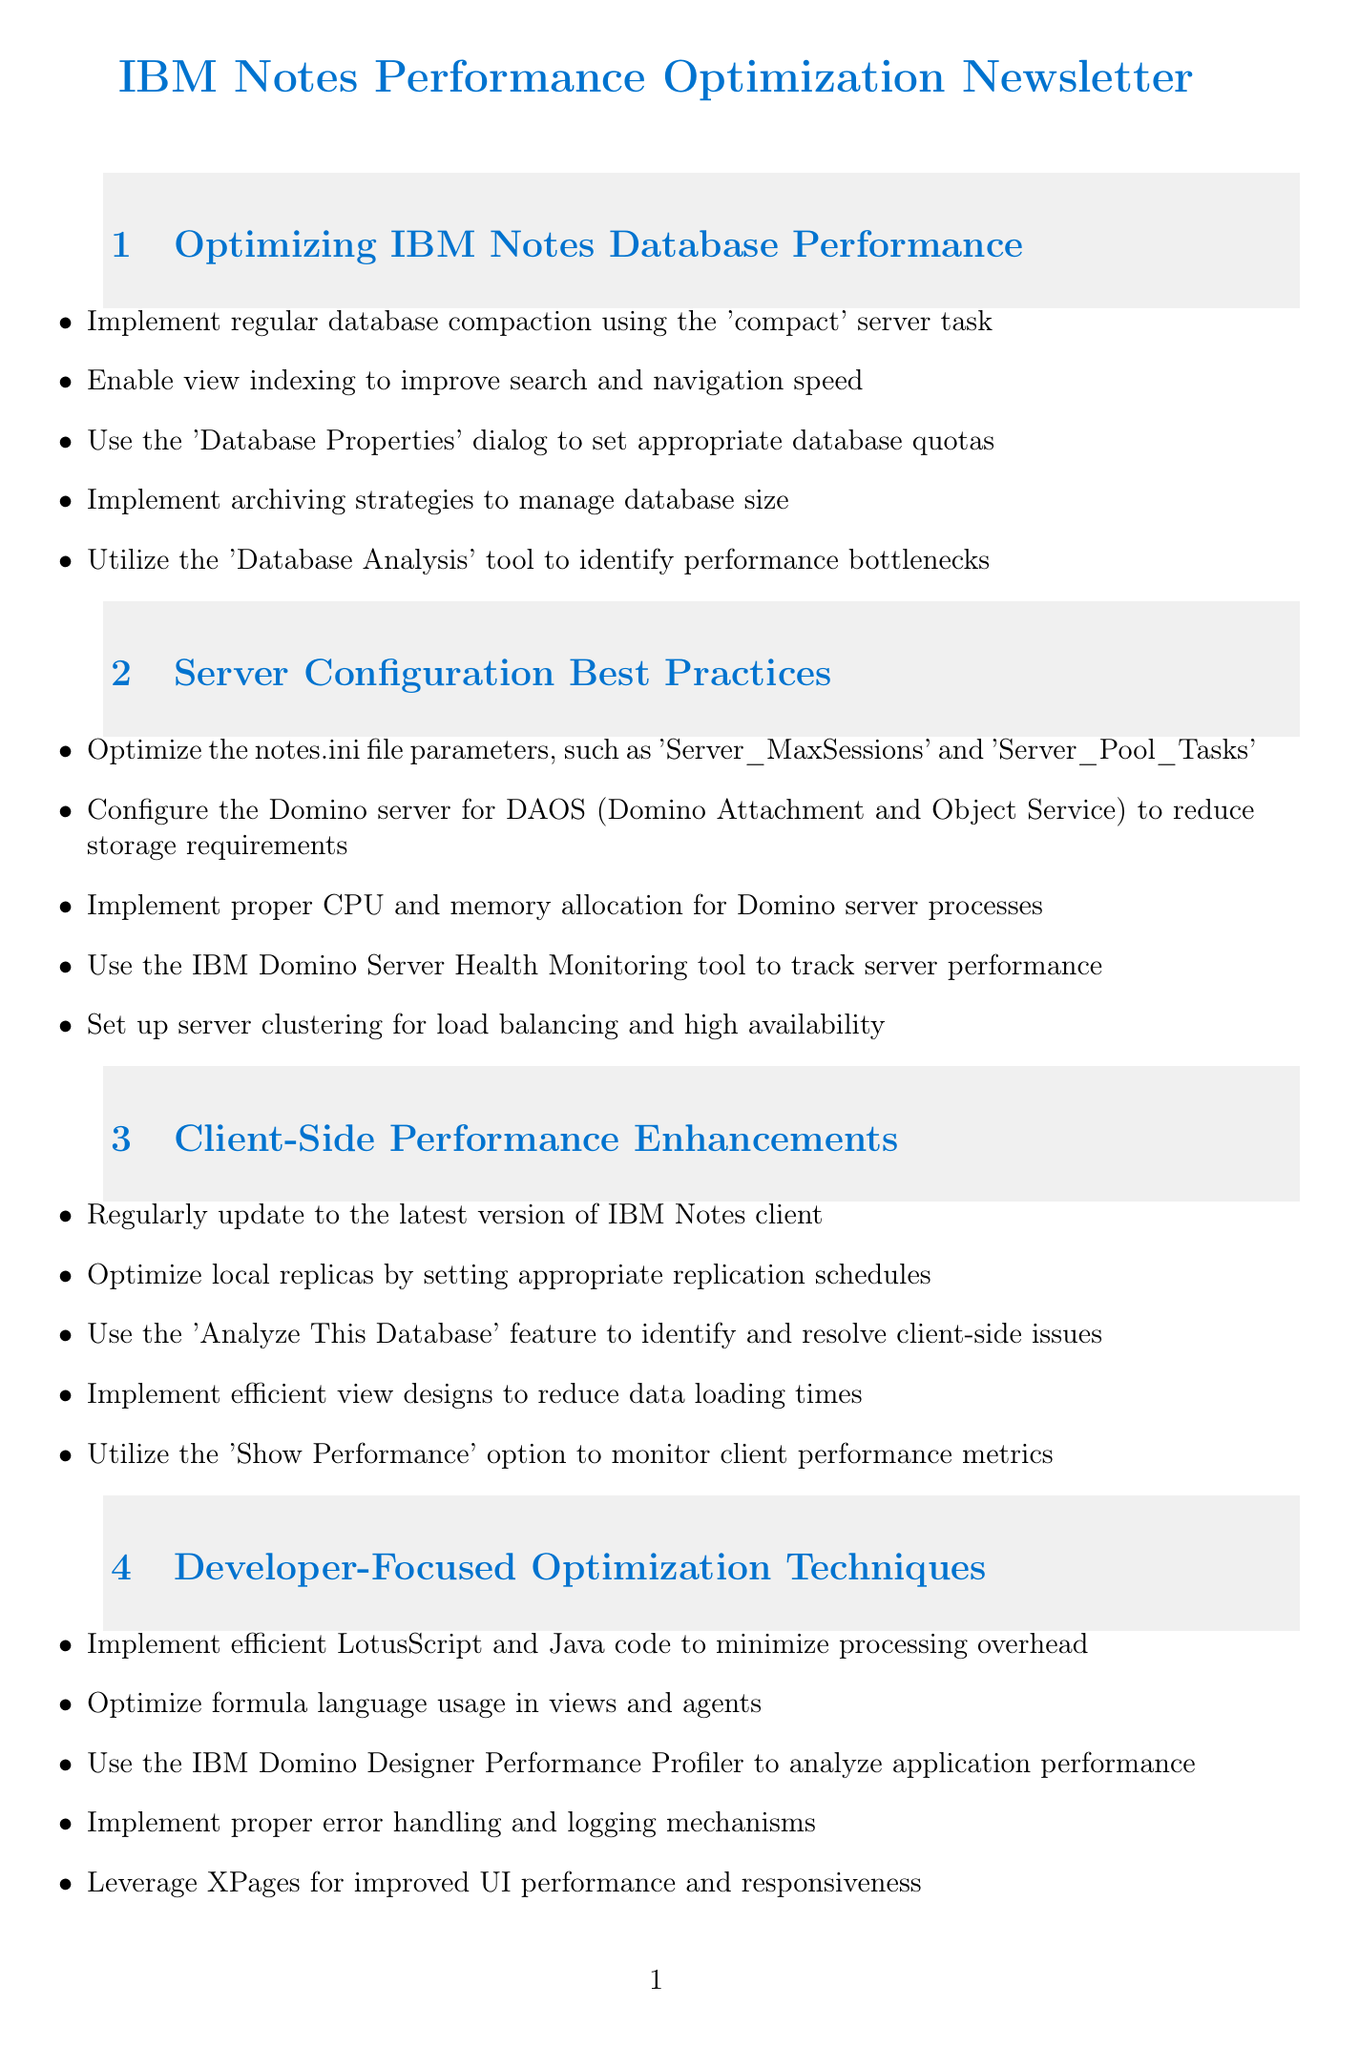What is the first tip for optimizing database performance? The first tip listed is to implement regular database compaction using the 'compact' server task.
Answer: Implement regular database compaction using the 'compact' server task What tool is suggested for tracking server performance? The document suggests using the IBM Domino Server Health Monitoring tool.
Answer: IBM Domino Server Health Monitoring tool What is DAOS? DAOS stands for Domino Attachment and Object Service, which is mentioned in the server configuration section.
Answer: Domino Attachment and Object Service Which programming languages are mentioned for optimization techniques? The languages mentioned are LotusScript and Java.
Answer: LotusScript and Java What is one resource for continuous learning? One resource for continuous learning is the IBM Technotes blog.
Answer: IBM Technotes blog How many client-side performance enhancement tips are provided? The document provides five tips for client-side performance enhancements.
Answer: Five Which section focuses specifically on optimizing code? The section that focuses on optimizing code is titled "Developer-Focused Optimization Techniques."
Answer: Developer-Focused Optimization Techniques What should be regularly updated to improve client performance? The document advises to regularly update to the latest version of IBM Notes client.
Answer: The latest version of IBM Notes client 